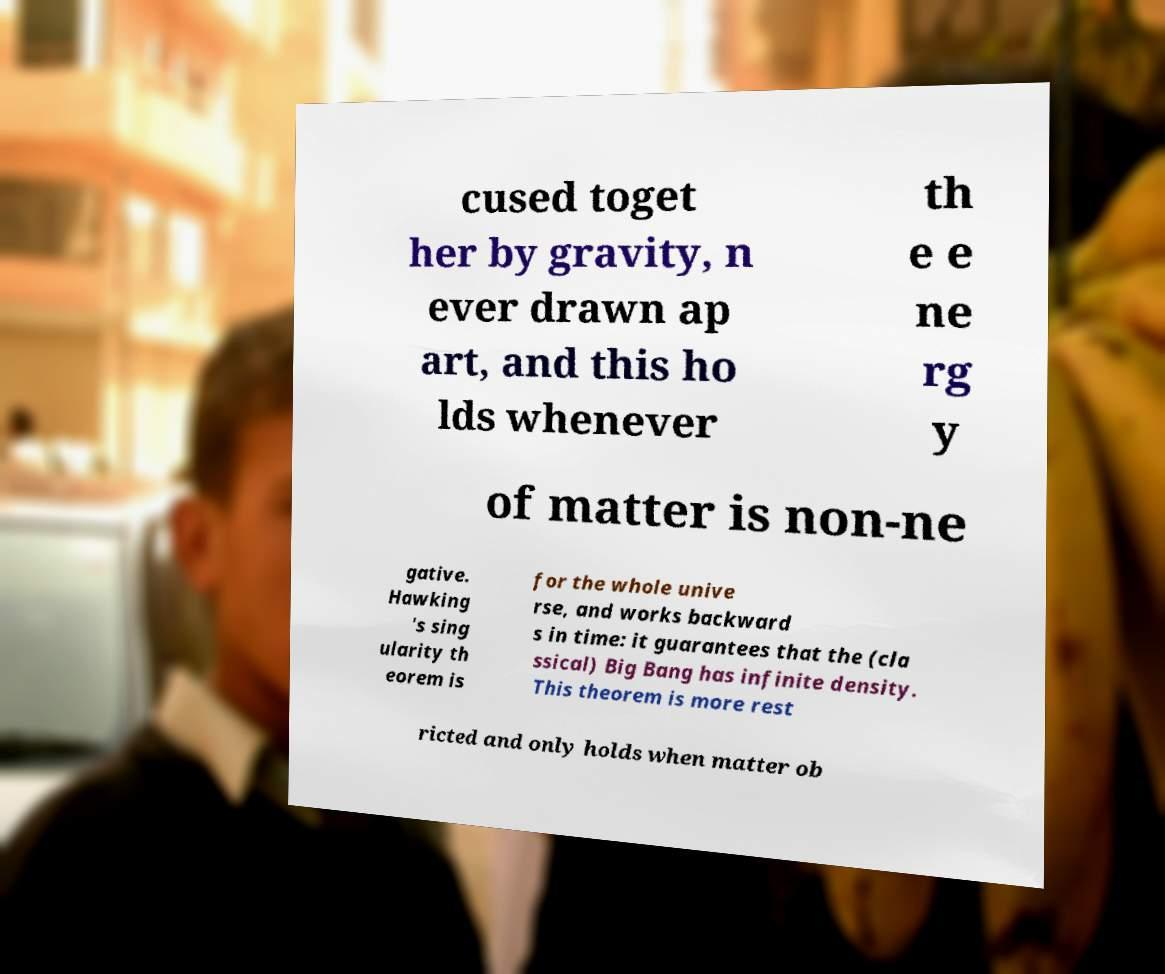Could you extract and type out the text from this image? cused toget her by gravity, n ever drawn ap art, and this ho lds whenever th e e ne rg y of matter is non-ne gative. Hawking 's sing ularity th eorem is for the whole unive rse, and works backward s in time: it guarantees that the (cla ssical) Big Bang has infinite density. This theorem is more rest ricted and only holds when matter ob 